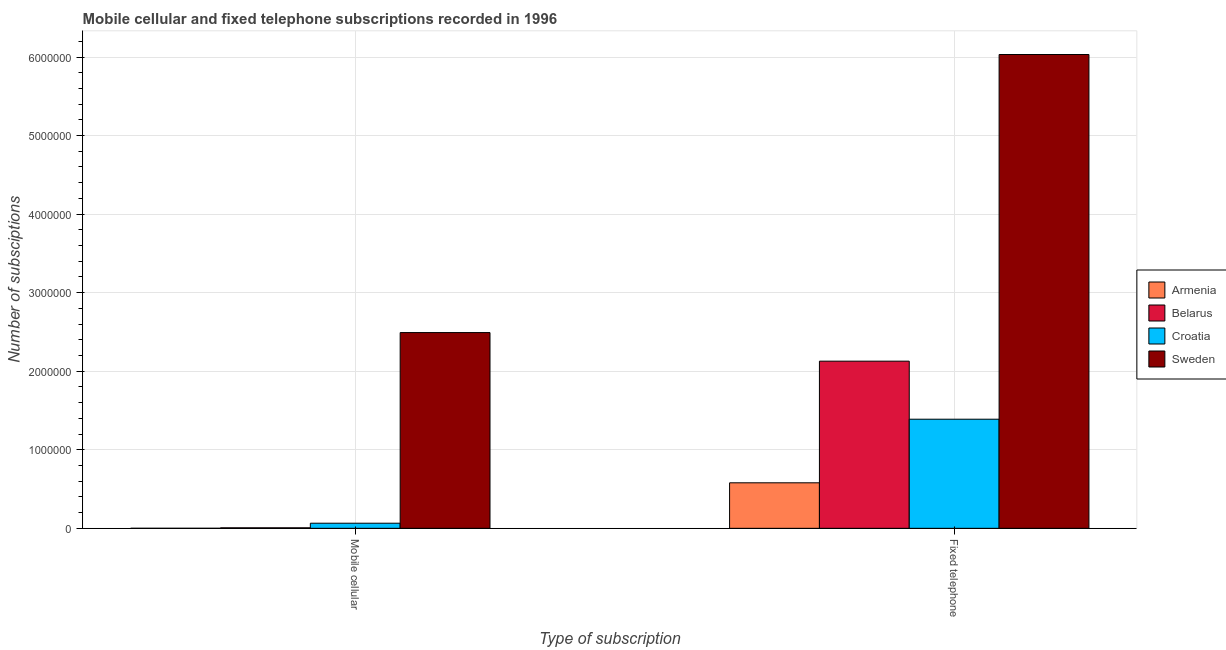How many different coloured bars are there?
Offer a very short reply. 4. Are the number of bars per tick equal to the number of legend labels?
Make the answer very short. Yes. Are the number of bars on each tick of the X-axis equal?
Your answer should be compact. Yes. What is the label of the 1st group of bars from the left?
Provide a short and direct response. Mobile cellular. What is the number of mobile cellular subscriptions in Belarus?
Your answer should be compact. 6548. Across all countries, what is the maximum number of fixed telephone subscriptions?
Provide a succinct answer. 6.03e+06. Across all countries, what is the minimum number of mobile cellular subscriptions?
Offer a terse response. 300. In which country was the number of mobile cellular subscriptions maximum?
Offer a very short reply. Sweden. In which country was the number of mobile cellular subscriptions minimum?
Give a very brief answer. Armenia. What is the total number of fixed telephone subscriptions in the graph?
Offer a terse response. 1.01e+07. What is the difference between the number of mobile cellular subscriptions in Armenia and that in Belarus?
Your response must be concise. -6248. What is the difference between the number of fixed telephone subscriptions in Croatia and the number of mobile cellular subscriptions in Armenia?
Make the answer very short. 1.39e+06. What is the average number of fixed telephone subscriptions per country?
Provide a short and direct response. 2.53e+06. What is the difference between the number of mobile cellular subscriptions and number of fixed telephone subscriptions in Belarus?
Provide a succinct answer. -2.12e+06. In how many countries, is the number of mobile cellular subscriptions greater than 1800000 ?
Offer a terse response. 1. What is the ratio of the number of fixed telephone subscriptions in Belarus to that in Armenia?
Offer a terse response. 3.67. Is the number of mobile cellular subscriptions in Croatia less than that in Belarus?
Give a very brief answer. No. What does the 3rd bar from the left in Fixed telephone represents?
Keep it short and to the point. Croatia. How many countries are there in the graph?
Give a very brief answer. 4. What is the difference between two consecutive major ticks on the Y-axis?
Offer a terse response. 1.00e+06. Are the values on the major ticks of Y-axis written in scientific E-notation?
Keep it short and to the point. No. Does the graph contain any zero values?
Keep it short and to the point. No. Where does the legend appear in the graph?
Offer a terse response. Center right. What is the title of the graph?
Offer a terse response. Mobile cellular and fixed telephone subscriptions recorded in 1996. Does "Brazil" appear as one of the legend labels in the graph?
Provide a short and direct response. No. What is the label or title of the X-axis?
Give a very brief answer. Type of subscription. What is the label or title of the Y-axis?
Provide a succinct answer. Number of subsciptions. What is the Number of subsciptions of Armenia in Mobile cellular?
Provide a succinct answer. 300. What is the Number of subsciptions of Belarus in Mobile cellular?
Offer a terse response. 6548. What is the Number of subsciptions in Croatia in Mobile cellular?
Provide a short and direct response. 6.49e+04. What is the Number of subsciptions in Sweden in Mobile cellular?
Your answer should be compact. 2.49e+06. What is the Number of subsciptions of Armenia in Fixed telephone?
Provide a short and direct response. 5.80e+05. What is the Number of subsciptions of Belarus in Fixed telephone?
Give a very brief answer. 2.13e+06. What is the Number of subsciptions of Croatia in Fixed telephone?
Offer a terse response. 1.39e+06. What is the Number of subsciptions of Sweden in Fixed telephone?
Give a very brief answer. 6.03e+06. Across all Type of subscription, what is the maximum Number of subsciptions of Armenia?
Offer a terse response. 5.80e+05. Across all Type of subscription, what is the maximum Number of subsciptions in Belarus?
Offer a very short reply. 2.13e+06. Across all Type of subscription, what is the maximum Number of subsciptions of Croatia?
Ensure brevity in your answer.  1.39e+06. Across all Type of subscription, what is the maximum Number of subsciptions in Sweden?
Offer a terse response. 6.03e+06. Across all Type of subscription, what is the minimum Number of subsciptions of Armenia?
Provide a succinct answer. 300. Across all Type of subscription, what is the minimum Number of subsciptions in Belarus?
Give a very brief answer. 6548. Across all Type of subscription, what is the minimum Number of subsciptions of Croatia?
Your answer should be compact. 6.49e+04. Across all Type of subscription, what is the minimum Number of subsciptions of Sweden?
Your answer should be compact. 2.49e+06. What is the total Number of subsciptions in Armenia in the graph?
Your answer should be compact. 5.80e+05. What is the total Number of subsciptions in Belarus in the graph?
Your answer should be compact. 2.13e+06. What is the total Number of subsciptions of Croatia in the graph?
Your answer should be compact. 1.45e+06. What is the total Number of subsciptions in Sweden in the graph?
Your answer should be compact. 8.52e+06. What is the difference between the Number of subsciptions of Armenia in Mobile cellular and that in Fixed telephone?
Provide a succinct answer. -5.79e+05. What is the difference between the Number of subsciptions in Belarus in Mobile cellular and that in Fixed telephone?
Give a very brief answer. -2.12e+06. What is the difference between the Number of subsciptions of Croatia in Mobile cellular and that in Fixed telephone?
Provide a short and direct response. -1.32e+06. What is the difference between the Number of subsciptions in Sweden in Mobile cellular and that in Fixed telephone?
Make the answer very short. -3.54e+06. What is the difference between the Number of subsciptions in Armenia in Mobile cellular and the Number of subsciptions in Belarus in Fixed telephone?
Offer a very short reply. -2.13e+06. What is the difference between the Number of subsciptions of Armenia in Mobile cellular and the Number of subsciptions of Croatia in Fixed telephone?
Ensure brevity in your answer.  -1.39e+06. What is the difference between the Number of subsciptions of Armenia in Mobile cellular and the Number of subsciptions of Sweden in Fixed telephone?
Give a very brief answer. -6.03e+06. What is the difference between the Number of subsciptions of Belarus in Mobile cellular and the Number of subsciptions of Croatia in Fixed telephone?
Your response must be concise. -1.38e+06. What is the difference between the Number of subsciptions of Belarus in Mobile cellular and the Number of subsciptions of Sweden in Fixed telephone?
Offer a very short reply. -6.03e+06. What is the difference between the Number of subsciptions of Croatia in Mobile cellular and the Number of subsciptions of Sweden in Fixed telephone?
Provide a short and direct response. -5.97e+06. What is the average Number of subsciptions of Armenia per Type of subscription?
Give a very brief answer. 2.90e+05. What is the average Number of subsciptions in Belarus per Type of subscription?
Your answer should be compact. 1.07e+06. What is the average Number of subsciptions of Croatia per Type of subscription?
Make the answer very short. 7.27e+05. What is the average Number of subsciptions of Sweden per Type of subscription?
Provide a succinct answer. 4.26e+06. What is the difference between the Number of subsciptions in Armenia and Number of subsciptions in Belarus in Mobile cellular?
Your answer should be compact. -6248. What is the difference between the Number of subsciptions in Armenia and Number of subsciptions in Croatia in Mobile cellular?
Keep it short and to the point. -6.46e+04. What is the difference between the Number of subsciptions in Armenia and Number of subsciptions in Sweden in Mobile cellular?
Your response must be concise. -2.49e+06. What is the difference between the Number of subsciptions in Belarus and Number of subsciptions in Croatia in Mobile cellular?
Your answer should be very brief. -5.84e+04. What is the difference between the Number of subsciptions of Belarus and Number of subsciptions of Sweden in Mobile cellular?
Give a very brief answer. -2.49e+06. What is the difference between the Number of subsciptions in Croatia and Number of subsciptions in Sweden in Mobile cellular?
Your response must be concise. -2.43e+06. What is the difference between the Number of subsciptions of Armenia and Number of subsciptions of Belarus in Fixed telephone?
Provide a short and direct response. -1.55e+06. What is the difference between the Number of subsciptions of Armenia and Number of subsciptions of Croatia in Fixed telephone?
Give a very brief answer. -8.10e+05. What is the difference between the Number of subsciptions in Armenia and Number of subsciptions in Sweden in Fixed telephone?
Make the answer very short. -5.45e+06. What is the difference between the Number of subsciptions of Belarus and Number of subsciptions of Croatia in Fixed telephone?
Ensure brevity in your answer.  7.39e+05. What is the difference between the Number of subsciptions in Belarus and Number of subsciptions in Sweden in Fixed telephone?
Your response must be concise. -3.90e+06. What is the difference between the Number of subsciptions in Croatia and Number of subsciptions in Sweden in Fixed telephone?
Keep it short and to the point. -4.64e+06. What is the ratio of the Number of subsciptions in Belarus in Mobile cellular to that in Fixed telephone?
Your response must be concise. 0. What is the ratio of the Number of subsciptions in Croatia in Mobile cellular to that in Fixed telephone?
Your response must be concise. 0.05. What is the ratio of the Number of subsciptions of Sweden in Mobile cellular to that in Fixed telephone?
Ensure brevity in your answer.  0.41. What is the difference between the highest and the second highest Number of subsciptions in Armenia?
Offer a very short reply. 5.79e+05. What is the difference between the highest and the second highest Number of subsciptions in Belarus?
Your answer should be compact. 2.12e+06. What is the difference between the highest and the second highest Number of subsciptions in Croatia?
Your response must be concise. 1.32e+06. What is the difference between the highest and the second highest Number of subsciptions of Sweden?
Your answer should be compact. 3.54e+06. What is the difference between the highest and the lowest Number of subsciptions of Armenia?
Your response must be concise. 5.79e+05. What is the difference between the highest and the lowest Number of subsciptions in Belarus?
Keep it short and to the point. 2.12e+06. What is the difference between the highest and the lowest Number of subsciptions of Croatia?
Give a very brief answer. 1.32e+06. What is the difference between the highest and the lowest Number of subsciptions of Sweden?
Provide a succinct answer. 3.54e+06. 